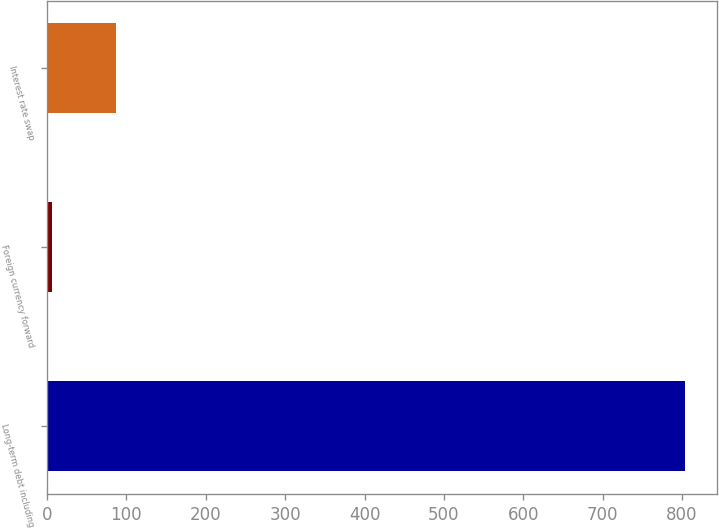Convert chart to OTSL. <chart><loc_0><loc_0><loc_500><loc_500><bar_chart><fcel>Long-term debt including<fcel>Foreign currency forward<fcel>Interest rate swap<nl><fcel>803.7<fcel>6.6<fcel>86.31<nl></chart> 